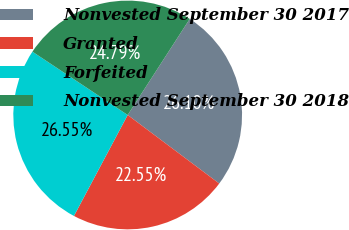Convert chart. <chart><loc_0><loc_0><loc_500><loc_500><pie_chart><fcel>Nonvested September 30 2017<fcel>Granted<fcel>Forfeited<fcel>Nonvested September 30 2018<nl><fcel>26.1%<fcel>22.55%<fcel>26.55%<fcel>24.79%<nl></chart> 